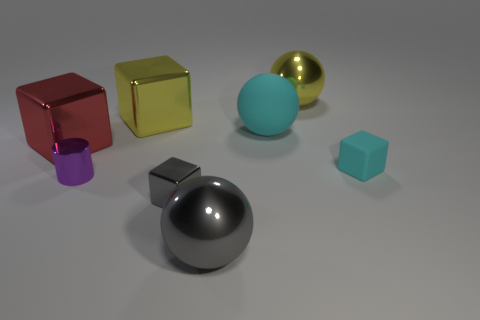Subtract all metal spheres. How many spheres are left? 1 Add 1 large purple rubber things. How many objects exist? 9 Subtract all cyan cubes. How many cubes are left? 3 Subtract 1 spheres. How many spheres are left? 2 Subtract all green blocks. Subtract all purple spheres. How many blocks are left? 4 Subtract all cyan metallic objects. Subtract all gray shiny objects. How many objects are left? 6 Add 3 large matte spheres. How many large matte spheres are left? 4 Add 3 tiny gray rubber spheres. How many tiny gray rubber spheres exist? 3 Subtract 0 green spheres. How many objects are left? 8 Subtract all spheres. How many objects are left? 5 